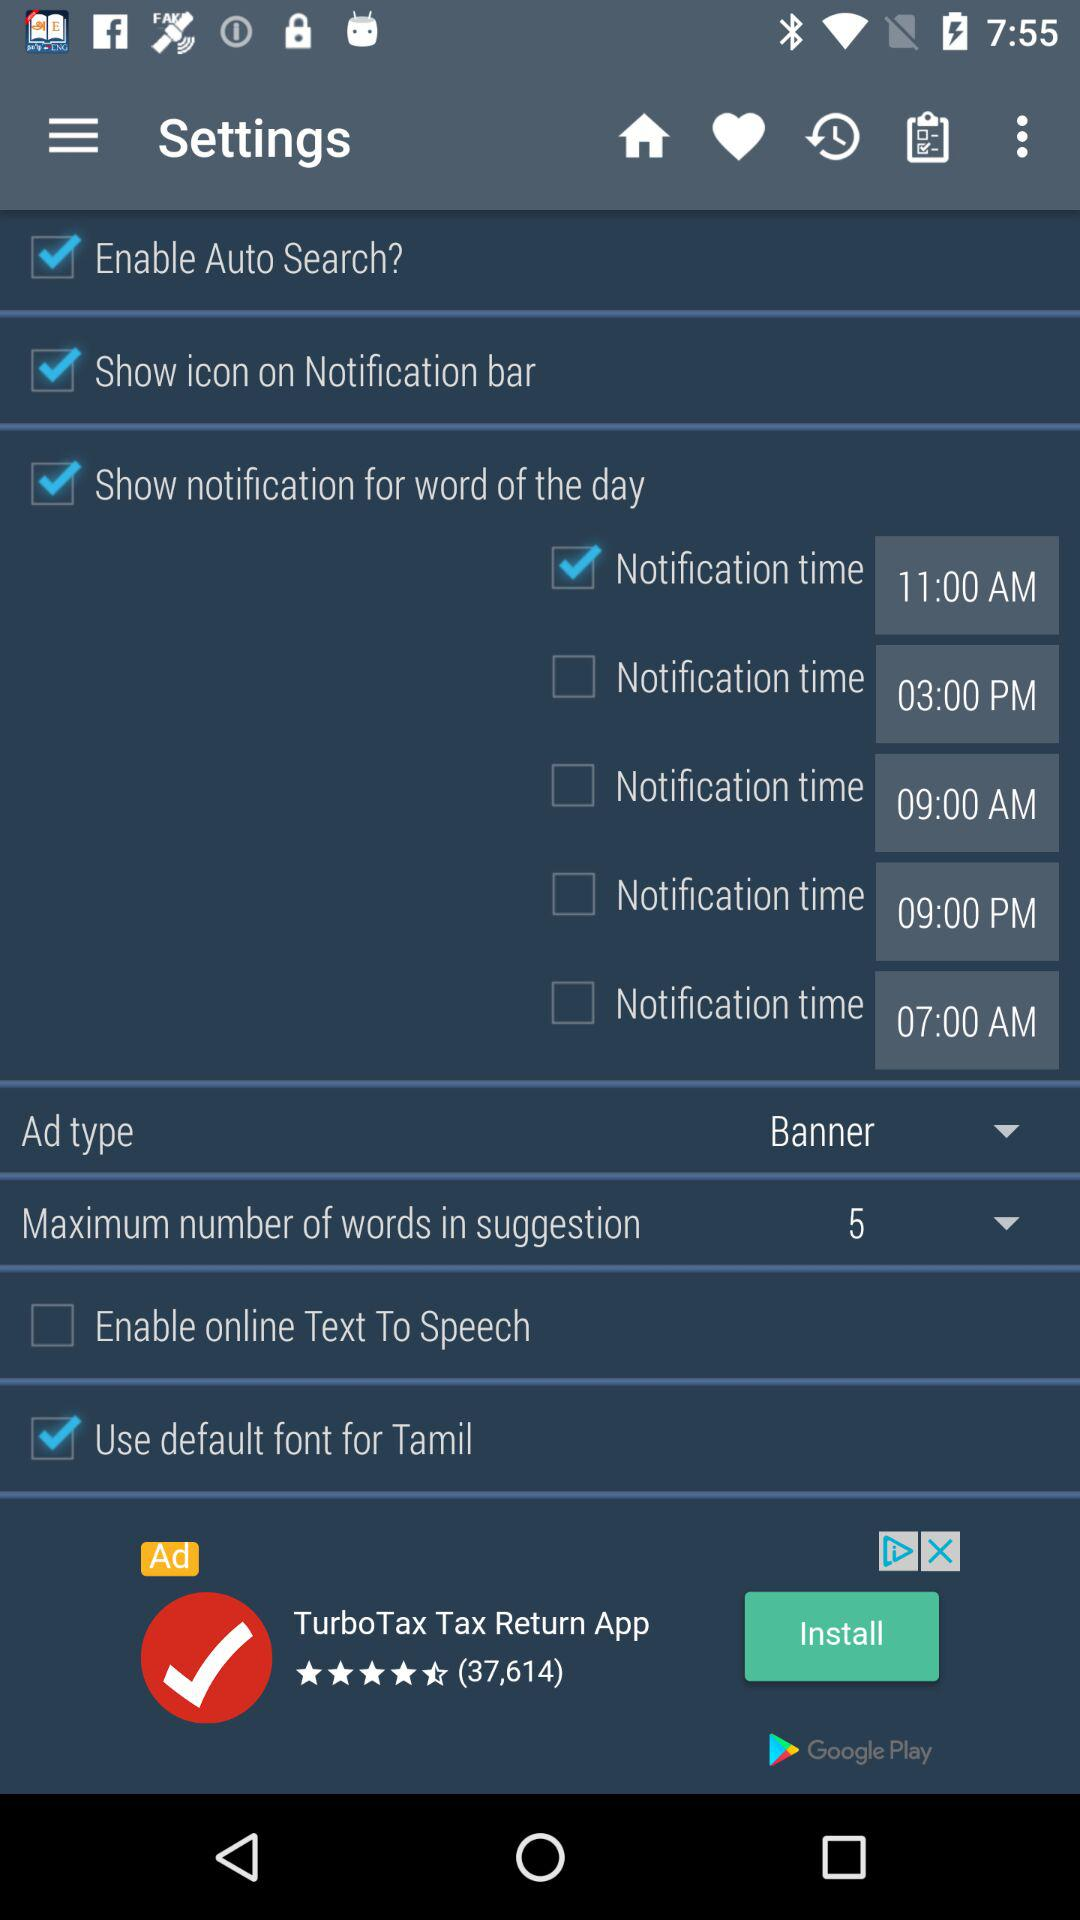How many notification times are available?
Answer the question using a single word or phrase. 5 